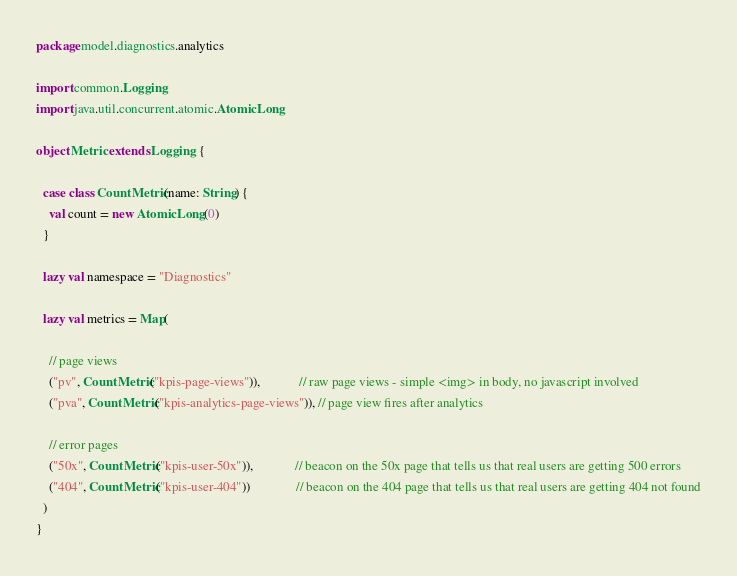<code> <loc_0><loc_0><loc_500><loc_500><_Scala_>package model.diagnostics.analytics

import common.Logging
import java.util.concurrent.atomic.AtomicLong

object Metric extends Logging {

  case class CountMetric(name: String) {
    val count = new AtomicLong(0)
  }

  lazy val namespace = "Diagnostics"

  lazy val metrics = Map(

    // page views
    ("pv", CountMetric("kpis-page-views")),            // raw page views - simple <img> in body, no javascript involved
    ("pva", CountMetric("kpis-analytics-page-views")), // page view fires after analytics

    // error pages
    ("50x", CountMetric("kpis-user-50x")),             // beacon on the 50x page that tells us that real users are getting 500 errors
    ("404", CountMetric("kpis-user-404"))              // beacon on the 404 page that tells us that real users are getting 404 not found
  )
}
</code> 